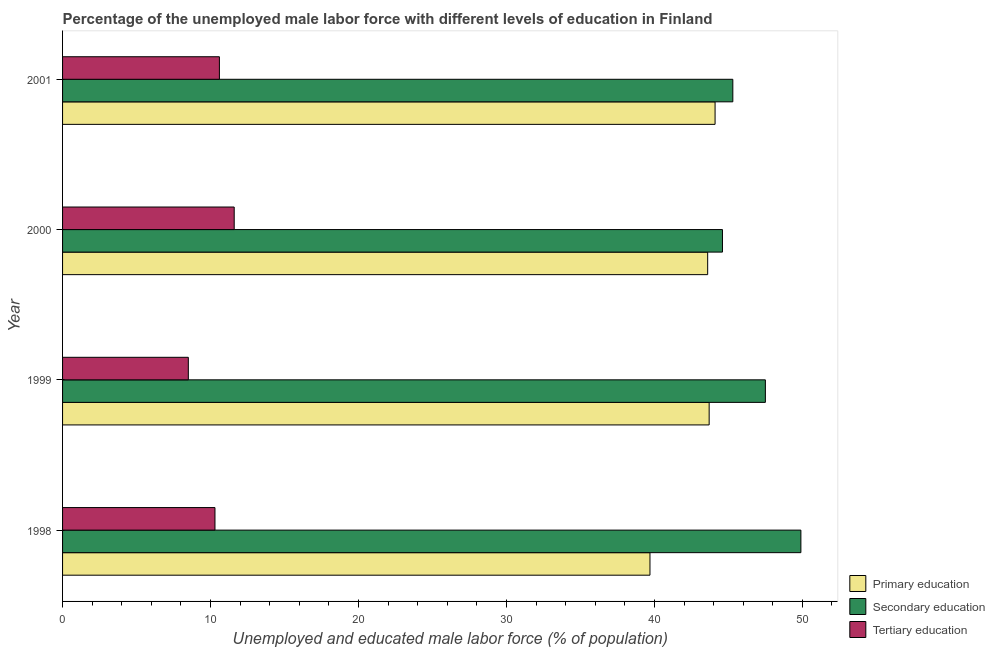How many different coloured bars are there?
Provide a short and direct response. 3. How many groups of bars are there?
Give a very brief answer. 4. Are the number of bars on each tick of the Y-axis equal?
Your answer should be very brief. Yes. How many bars are there on the 3rd tick from the top?
Your answer should be compact. 3. How many bars are there on the 1st tick from the bottom?
Provide a succinct answer. 3. What is the label of the 3rd group of bars from the top?
Your answer should be very brief. 1999. What is the percentage of male labor force who received primary education in 2000?
Keep it short and to the point. 43.6. Across all years, what is the maximum percentage of male labor force who received secondary education?
Your answer should be compact. 49.9. Across all years, what is the minimum percentage of male labor force who received secondary education?
Your answer should be very brief. 44.6. In which year was the percentage of male labor force who received secondary education maximum?
Make the answer very short. 1998. In which year was the percentage of male labor force who received primary education minimum?
Ensure brevity in your answer.  1998. What is the total percentage of male labor force who received secondary education in the graph?
Provide a short and direct response. 187.3. What is the difference between the percentage of male labor force who received secondary education in 1998 and that in 1999?
Offer a terse response. 2.4. What is the difference between the percentage of male labor force who received tertiary education in 2001 and the percentage of male labor force who received secondary education in 2000?
Give a very brief answer. -34. What is the average percentage of male labor force who received primary education per year?
Provide a short and direct response. 42.77. What is the ratio of the percentage of male labor force who received secondary education in 1998 to that in 2000?
Your answer should be compact. 1.12. Is the difference between the percentage of male labor force who received tertiary education in 1999 and 2000 greater than the difference between the percentage of male labor force who received primary education in 1999 and 2000?
Offer a very short reply. No. In how many years, is the percentage of male labor force who received tertiary education greater than the average percentage of male labor force who received tertiary education taken over all years?
Your answer should be compact. 3. Is the sum of the percentage of male labor force who received secondary education in 1999 and 2001 greater than the maximum percentage of male labor force who received tertiary education across all years?
Provide a short and direct response. Yes. What does the 1st bar from the top in 1999 represents?
Your answer should be very brief. Tertiary education. What does the 1st bar from the bottom in 2001 represents?
Ensure brevity in your answer.  Primary education. Is it the case that in every year, the sum of the percentage of male labor force who received primary education and percentage of male labor force who received secondary education is greater than the percentage of male labor force who received tertiary education?
Your response must be concise. Yes. How many bars are there?
Give a very brief answer. 12. Does the graph contain any zero values?
Your response must be concise. No. Where does the legend appear in the graph?
Your answer should be compact. Bottom right. How many legend labels are there?
Give a very brief answer. 3. What is the title of the graph?
Ensure brevity in your answer.  Percentage of the unemployed male labor force with different levels of education in Finland. What is the label or title of the X-axis?
Make the answer very short. Unemployed and educated male labor force (% of population). What is the label or title of the Y-axis?
Provide a succinct answer. Year. What is the Unemployed and educated male labor force (% of population) of Primary education in 1998?
Your response must be concise. 39.7. What is the Unemployed and educated male labor force (% of population) of Secondary education in 1998?
Your answer should be very brief. 49.9. What is the Unemployed and educated male labor force (% of population) of Tertiary education in 1998?
Make the answer very short. 10.3. What is the Unemployed and educated male labor force (% of population) in Primary education in 1999?
Keep it short and to the point. 43.7. What is the Unemployed and educated male labor force (% of population) in Secondary education in 1999?
Provide a short and direct response. 47.5. What is the Unemployed and educated male labor force (% of population) in Tertiary education in 1999?
Provide a short and direct response. 8.5. What is the Unemployed and educated male labor force (% of population) in Primary education in 2000?
Provide a succinct answer. 43.6. What is the Unemployed and educated male labor force (% of population) of Secondary education in 2000?
Provide a short and direct response. 44.6. What is the Unemployed and educated male labor force (% of population) in Tertiary education in 2000?
Your answer should be very brief. 11.6. What is the Unemployed and educated male labor force (% of population) of Primary education in 2001?
Keep it short and to the point. 44.1. What is the Unemployed and educated male labor force (% of population) in Secondary education in 2001?
Keep it short and to the point. 45.3. What is the Unemployed and educated male labor force (% of population) in Tertiary education in 2001?
Make the answer very short. 10.6. Across all years, what is the maximum Unemployed and educated male labor force (% of population) in Primary education?
Keep it short and to the point. 44.1. Across all years, what is the maximum Unemployed and educated male labor force (% of population) of Secondary education?
Provide a succinct answer. 49.9. Across all years, what is the maximum Unemployed and educated male labor force (% of population) of Tertiary education?
Your answer should be compact. 11.6. Across all years, what is the minimum Unemployed and educated male labor force (% of population) of Primary education?
Offer a very short reply. 39.7. Across all years, what is the minimum Unemployed and educated male labor force (% of population) in Secondary education?
Provide a succinct answer. 44.6. What is the total Unemployed and educated male labor force (% of population) in Primary education in the graph?
Offer a terse response. 171.1. What is the total Unemployed and educated male labor force (% of population) of Secondary education in the graph?
Your answer should be very brief. 187.3. What is the total Unemployed and educated male labor force (% of population) in Tertiary education in the graph?
Keep it short and to the point. 41. What is the difference between the Unemployed and educated male labor force (% of population) in Primary education in 1998 and that in 1999?
Keep it short and to the point. -4. What is the difference between the Unemployed and educated male labor force (% of population) in Primary education in 1998 and that in 2001?
Offer a very short reply. -4.4. What is the difference between the Unemployed and educated male labor force (% of population) in Primary education in 1999 and that in 2000?
Offer a terse response. 0.1. What is the difference between the Unemployed and educated male labor force (% of population) in Primary education in 1999 and that in 2001?
Provide a short and direct response. -0.4. What is the difference between the Unemployed and educated male labor force (% of population) of Secondary education in 1999 and that in 2001?
Offer a very short reply. 2.2. What is the difference between the Unemployed and educated male labor force (% of population) of Tertiary education in 1999 and that in 2001?
Your response must be concise. -2.1. What is the difference between the Unemployed and educated male labor force (% of population) of Primary education in 2000 and that in 2001?
Give a very brief answer. -0.5. What is the difference between the Unemployed and educated male labor force (% of population) of Tertiary education in 2000 and that in 2001?
Ensure brevity in your answer.  1. What is the difference between the Unemployed and educated male labor force (% of population) in Primary education in 1998 and the Unemployed and educated male labor force (% of population) in Secondary education in 1999?
Your response must be concise. -7.8. What is the difference between the Unemployed and educated male labor force (% of population) in Primary education in 1998 and the Unemployed and educated male labor force (% of population) in Tertiary education in 1999?
Ensure brevity in your answer.  31.2. What is the difference between the Unemployed and educated male labor force (% of population) in Secondary education in 1998 and the Unemployed and educated male labor force (% of population) in Tertiary education in 1999?
Your answer should be very brief. 41.4. What is the difference between the Unemployed and educated male labor force (% of population) of Primary education in 1998 and the Unemployed and educated male labor force (% of population) of Secondary education in 2000?
Keep it short and to the point. -4.9. What is the difference between the Unemployed and educated male labor force (% of population) of Primary education in 1998 and the Unemployed and educated male labor force (% of population) of Tertiary education in 2000?
Make the answer very short. 28.1. What is the difference between the Unemployed and educated male labor force (% of population) in Secondary education in 1998 and the Unemployed and educated male labor force (% of population) in Tertiary education in 2000?
Provide a short and direct response. 38.3. What is the difference between the Unemployed and educated male labor force (% of population) of Primary education in 1998 and the Unemployed and educated male labor force (% of population) of Tertiary education in 2001?
Provide a short and direct response. 29.1. What is the difference between the Unemployed and educated male labor force (% of population) of Secondary education in 1998 and the Unemployed and educated male labor force (% of population) of Tertiary education in 2001?
Your response must be concise. 39.3. What is the difference between the Unemployed and educated male labor force (% of population) in Primary education in 1999 and the Unemployed and educated male labor force (% of population) in Secondary education in 2000?
Your response must be concise. -0.9. What is the difference between the Unemployed and educated male labor force (% of population) of Primary education in 1999 and the Unemployed and educated male labor force (% of population) of Tertiary education in 2000?
Your answer should be compact. 32.1. What is the difference between the Unemployed and educated male labor force (% of population) of Secondary education in 1999 and the Unemployed and educated male labor force (% of population) of Tertiary education in 2000?
Offer a very short reply. 35.9. What is the difference between the Unemployed and educated male labor force (% of population) in Primary education in 1999 and the Unemployed and educated male labor force (% of population) in Secondary education in 2001?
Keep it short and to the point. -1.6. What is the difference between the Unemployed and educated male labor force (% of population) in Primary education in 1999 and the Unemployed and educated male labor force (% of population) in Tertiary education in 2001?
Provide a short and direct response. 33.1. What is the difference between the Unemployed and educated male labor force (% of population) of Secondary education in 1999 and the Unemployed and educated male labor force (% of population) of Tertiary education in 2001?
Offer a very short reply. 36.9. What is the difference between the Unemployed and educated male labor force (% of population) of Secondary education in 2000 and the Unemployed and educated male labor force (% of population) of Tertiary education in 2001?
Make the answer very short. 34. What is the average Unemployed and educated male labor force (% of population) in Primary education per year?
Make the answer very short. 42.77. What is the average Unemployed and educated male labor force (% of population) in Secondary education per year?
Give a very brief answer. 46.83. What is the average Unemployed and educated male labor force (% of population) in Tertiary education per year?
Make the answer very short. 10.25. In the year 1998, what is the difference between the Unemployed and educated male labor force (% of population) of Primary education and Unemployed and educated male labor force (% of population) of Tertiary education?
Make the answer very short. 29.4. In the year 1998, what is the difference between the Unemployed and educated male labor force (% of population) in Secondary education and Unemployed and educated male labor force (% of population) in Tertiary education?
Your response must be concise. 39.6. In the year 1999, what is the difference between the Unemployed and educated male labor force (% of population) of Primary education and Unemployed and educated male labor force (% of population) of Secondary education?
Give a very brief answer. -3.8. In the year 1999, what is the difference between the Unemployed and educated male labor force (% of population) in Primary education and Unemployed and educated male labor force (% of population) in Tertiary education?
Provide a succinct answer. 35.2. In the year 1999, what is the difference between the Unemployed and educated male labor force (% of population) in Secondary education and Unemployed and educated male labor force (% of population) in Tertiary education?
Offer a very short reply. 39. In the year 2000, what is the difference between the Unemployed and educated male labor force (% of population) of Primary education and Unemployed and educated male labor force (% of population) of Secondary education?
Your response must be concise. -1. In the year 2000, what is the difference between the Unemployed and educated male labor force (% of population) of Primary education and Unemployed and educated male labor force (% of population) of Tertiary education?
Ensure brevity in your answer.  32. In the year 2001, what is the difference between the Unemployed and educated male labor force (% of population) in Primary education and Unemployed and educated male labor force (% of population) in Secondary education?
Provide a succinct answer. -1.2. In the year 2001, what is the difference between the Unemployed and educated male labor force (% of population) of Primary education and Unemployed and educated male labor force (% of population) of Tertiary education?
Provide a succinct answer. 33.5. In the year 2001, what is the difference between the Unemployed and educated male labor force (% of population) of Secondary education and Unemployed and educated male labor force (% of population) of Tertiary education?
Make the answer very short. 34.7. What is the ratio of the Unemployed and educated male labor force (% of population) of Primary education in 1998 to that in 1999?
Provide a short and direct response. 0.91. What is the ratio of the Unemployed and educated male labor force (% of population) in Secondary education in 1998 to that in 1999?
Provide a short and direct response. 1.05. What is the ratio of the Unemployed and educated male labor force (% of population) of Tertiary education in 1998 to that in 1999?
Give a very brief answer. 1.21. What is the ratio of the Unemployed and educated male labor force (% of population) in Primary education in 1998 to that in 2000?
Provide a succinct answer. 0.91. What is the ratio of the Unemployed and educated male labor force (% of population) in Secondary education in 1998 to that in 2000?
Offer a very short reply. 1.12. What is the ratio of the Unemployed and educated male labor force (% of population) in Tertiary education in 1998 to that in 2000?
Provide a short and direct response. 0.89. What is the ratio of the Unemployed and educated male labor force (% of population) of Primary education in 1998 to that in 2001?
Make the answer very short. 0.9. What is the ratio of the Unemployed and educated male labor force (% of population) in Secondary education in 1998 to that in 2001?
Offer a terse response. 1.1. What is the ratio of the Unemployed and educated male labor force (% of population) of Tertiary education in 1998 to that in 2001?
Ensure brevity in your answer.  0.97. What is the ratio of the Unemployed and educated male labor force (% of population) of Secondary education in 1999 to that in 2000?
Provide a short and direct response. 1.06. What is the ratio of the Unemployed and educated male labor force (% of population) in Tertiary education in 1999 to that in 2000?
Offer a terse response. 0.73. What is the ratio of the Unemployed and educated male labor force (% of population) of Primary education in 1999 to that in 2001?
Give a very brief answer. 0.99. What is the ratio of the Unemployed and educated male labor force (% of population) of Secondary education in 1999 to that in 2001?
Your answer should be very brief. 1.05. What is the ratio of the Unemployed and educated male labor force (% of population) of Tertiary education in 1999 to that in 2001?
Provide a succinct answer. 0.8. What is the ratio of the Unemployed and educated male labor force (% of population) of Primary education in 2000 to that in 2001?
Your answer should be compact. 0.99. What is the ratio of the Unemployed and educated male labor force (% of population) in Secondary education in 2000 to that in 2001?
Offer a very short reply. 0.98. What is the ratio of the Unemployed and educated male labor force (% of population) of Tertiary education in 2000 to that in 2001?
Provide a succinct answer. 1.09. What is the difference between the highest and the second highest Unemployed and educated male labor force (% of population) in Tertiary education?
Keep it short and to the point. 1. 